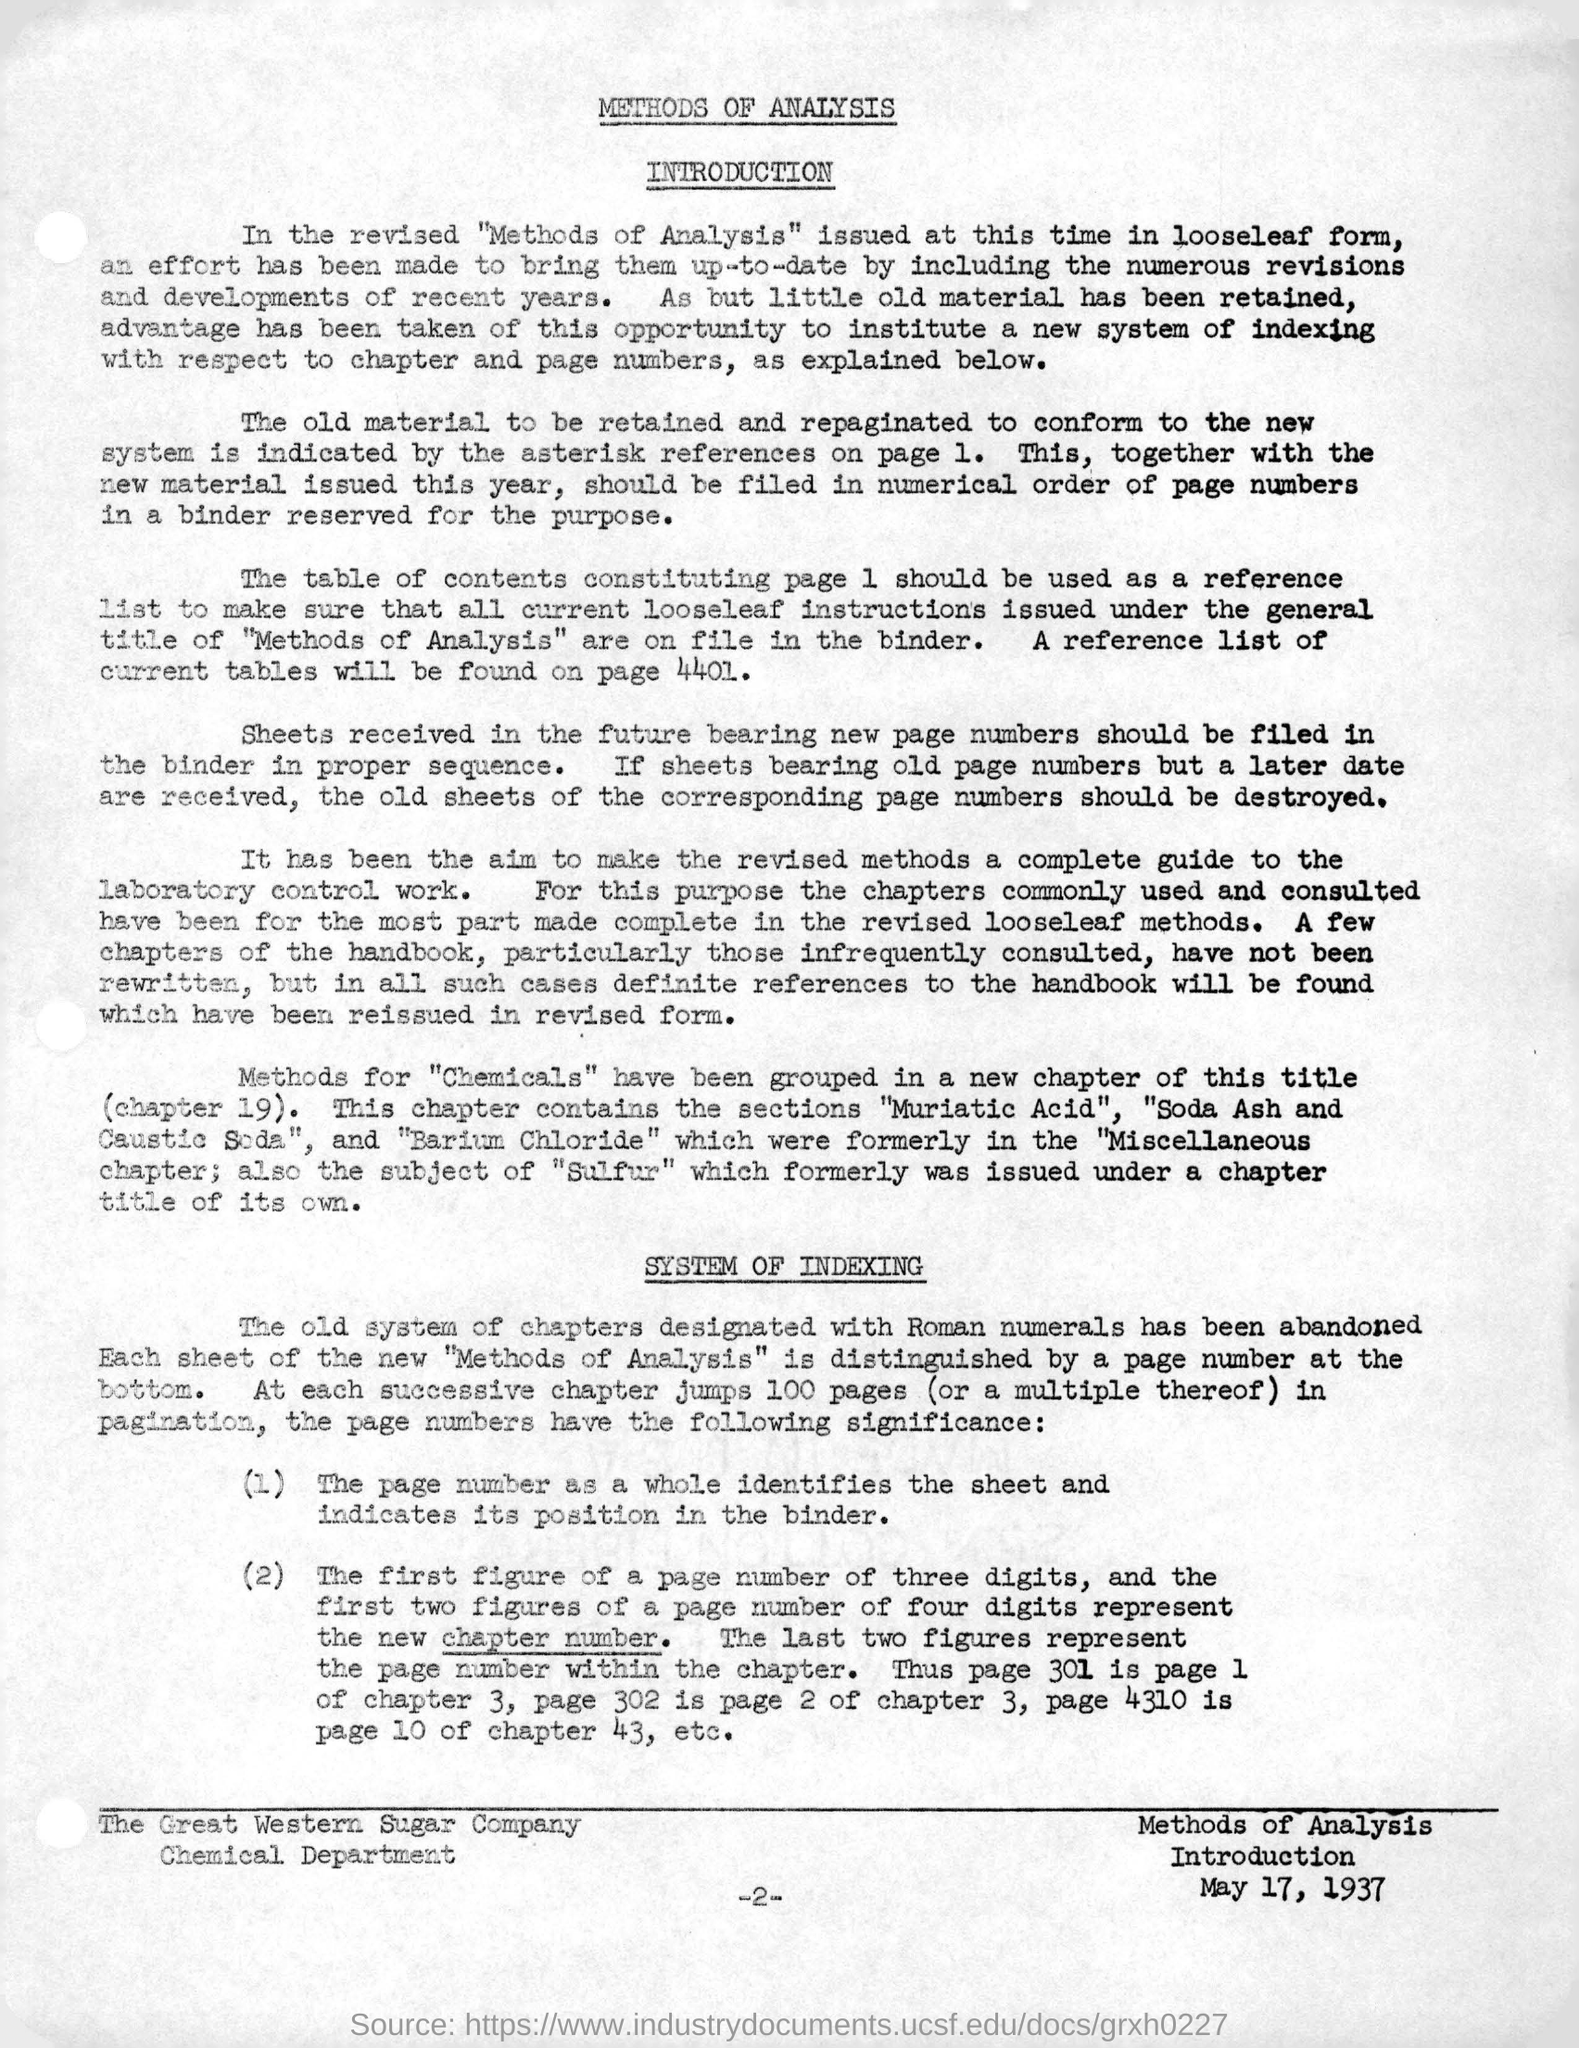What is this document about?
Ensure brevity in your answer.  METHODS OF ANALYSIS. What is the date mentioned in the right hand bottom corner of the document?
Ensure brevity in your answer.  May 17, 1937. What is the main title of the document?
Your answer should be compact. METHODS OF ANALYSIS. Which page shows the reference list of current tables?
Your response must be concise. 4401. 